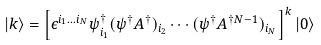<formula> <loc_0><loc_0><loc_500><loc_500>| k \rangle = \left [ \epsilon ^ { i _ { 1 } \dots i _ { N } } \psi ^ { \dag } _ { i _ { 1 } } ( \psi ^ { \dag } A ^ { \dag } ) _ { i _ { 2 } } \cdots ( \psi ^ { \dag } A ^ { \dag N - 1 } ) _ { i _ { N } } \right ] ^ { k } | 0 \rangle</formula> 